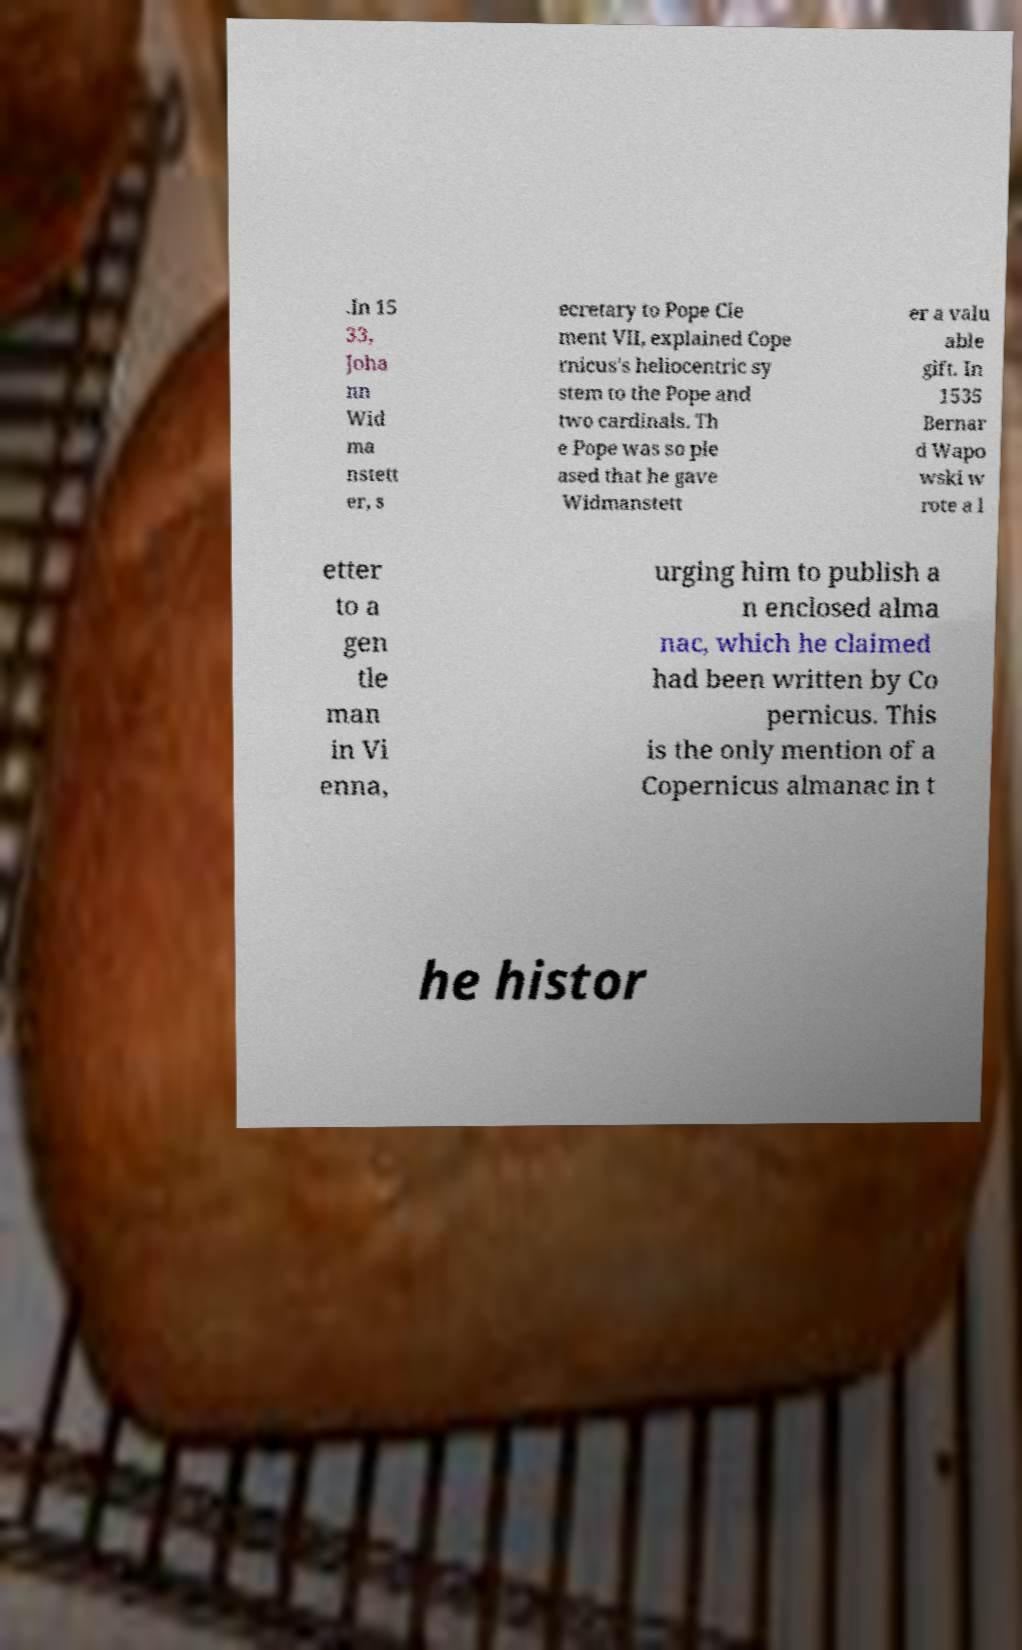Please identify and transcribe the text found in this image. .In 15 33, Joha nn Wid ma nstett er, s ecretary to Pope Cle ment VII, explained Cope rnicus's heliocentric sy stem to the Pope and two cardinals. Th e Pope was so ple ased that he gave Widmanstett er a valu able gift. In 1535 Bernar d Wapo wski w rote a l etter to a gen tle man in Vi enna, urging him to publish a n enclosed alma nac, which he claimed had been written by Co pernicus. This is the only mention of a Copernicus almanac in t he histor 